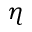<formula> <loc_0><loc_0><loc_500><loc_500>\eta</formula> 